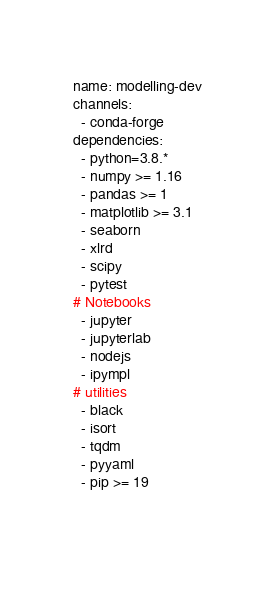<code> <loc_0><loc_0><loc_500><loc_500><_YAML_>name: modelling-dev
channels:
  - conda-forge
dependencies:
  - python=3.8.*
  - numpy >= 1.16
  - pandas >= 1
  - matplotlib >= 3.1
  - seaborn
  - xlrd
  - scipy
  - pytest
# Notebooks
  - jupyter
  - jupyterlab
  - nodejs
  - ipympl
# utilities
  - black
  - isort
  - tqdm
  - pyyaml
  - pip >= 19

  </code> 